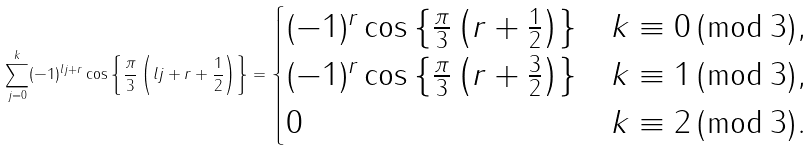<formula> <loc_0><loc_0><loc_500><loc_500>\sum _ { j = 0 } ^ { k } ( - 1 ) ^ { l j + r } \cos \left \{ \frac { \pi } { 3 } \left ( l j + r + \frac { 1 } { 2 } \right ) \right \} = \begin{cases} ( - 1 ) ^ { r } \cos \left \{ \frac { \pi } { 3 } \left ( r + \frac { 1 } { 2 } \right ) \right \} & k \equiv 0 \, ( \bmod \, 3 ) , \\ ( - 1 ) ^ { r } \cos \left \{ \frac { \pi } { 3 } \left ( r + \frac { 3 } { 2 } \right ) \right \} & k \equiv 1 \, ( \bmod \, 3 ) , \\ 0 & k \equiv 2 \, ( \bmod \, 3 ) . \end{cases}</formula> 